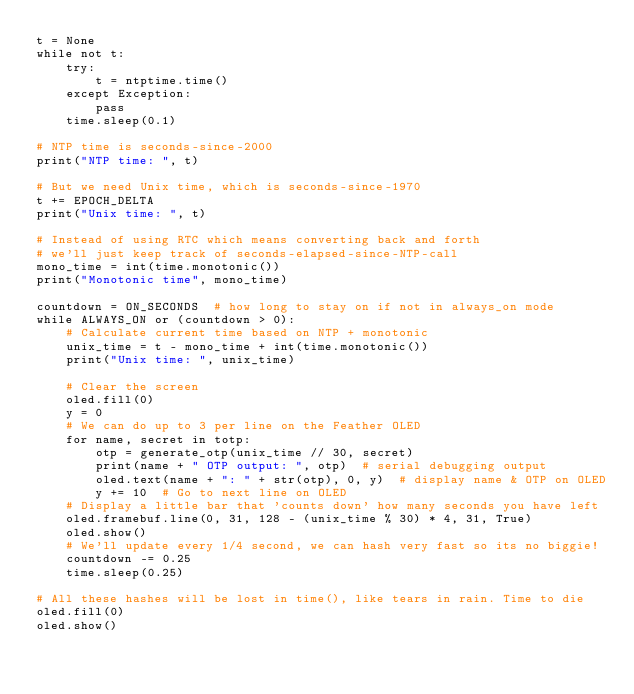<code> <loc_0><loc_0><loc_500><loc_500><_Python_>t = None
while not t:
    try:
        t = ntptime.time()
    except Exception:
        pass
    time.sleep(0.1)

# NTP time is seconds-since-2000
print("NTP time: ", t)

# But we need Unix time, which is seconds-since-1970
t += EPOCH_DELTA
print("Unix time: ", t)

# Instead of using RTC which means converting back and forth
# we'll just keep track of seconds-elapsed-since-NTP-call
mono_time = int(time.monotonic())
print("Monotonic time", mono_time)

countdown = ON_SECONDS  # how long to stay on if not in always_on mode
while ALWAYS_ON or (countdown > 0):
    # Calculate current time based on NTP + monotonic
    unix_time = t - mono_time + int(time.monotonic())
    print("Unix time: ", unix_time)

    # Clear the screen
    oled.fill(0)
    y = 0
    # We can do up to 3 per line on the Feather OLED
    for name, secret in totp:
        otp = generate_otp(unix_time // 30, secret)
        print(name + " OTP output: ", otp)  # serial debugging output
        oled.text(name + ": " + str(otp), 0, y)  # display name & OTP on OLED
        y += 10  # Go to next line on OLED
    # Display a little bar that 'counts down' how many seconds you have left
    oled.framebuf.line(0, 31, 128 - (unix_time % 30) * 4, 31, True)
    oled.show()
    # We'll update every 1/4 second, we can hash very fast so its no biggie!
    countdown -= 0.25
    time.sleep(0.25)

# All these hashes will be lost in time(), like tears in rain. Time to die
oled.fill(0)
oled.show()
</code> 